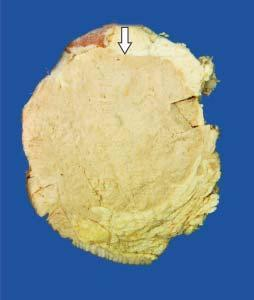does epithelial show a large grey white soft fleshy tumour replacing almost whole of the breast?
Answer the question using a single word or phrase. No 